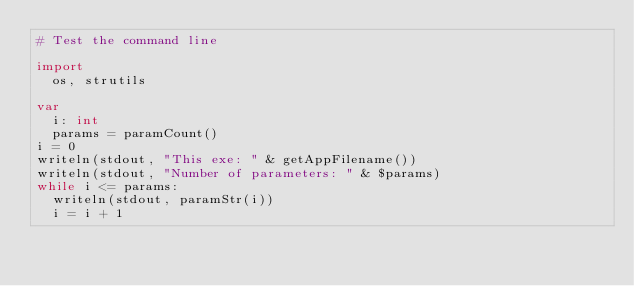Convert code to text. <code><loc_0><loc_0><loc_500><loc_500><_Nim_># Test the command line

import
  os, strutils

var
  i: int
  params = paramCount()
i = 0
writeln(stdout, "This exe: " & getAppFilename())
writeln(stdout, "Number of parameters: " & $params)
while i <= params:
  writeln(stdout, paramStr(i))
  i = i + 1
</code> 